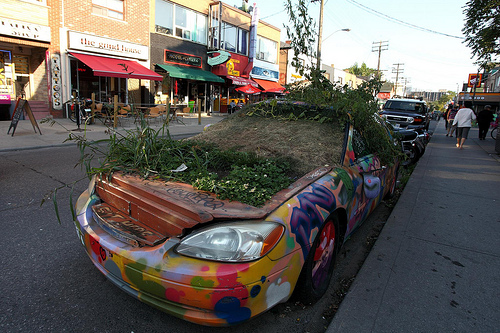<image>
Can you confirm if the car is under the dirt? No. The car is not positioned under the dirt. The vertical relationship between these objects is different. Where is the plant in relation to the car? Is it in the car? Yes. The plant is contained within or inside the car, showing a containment relationship. Where is the car in relation to the shop? Is it in front of the shop? Yes. The car is positioned in front of the shop, appearing closer to the camera viewpoint. 